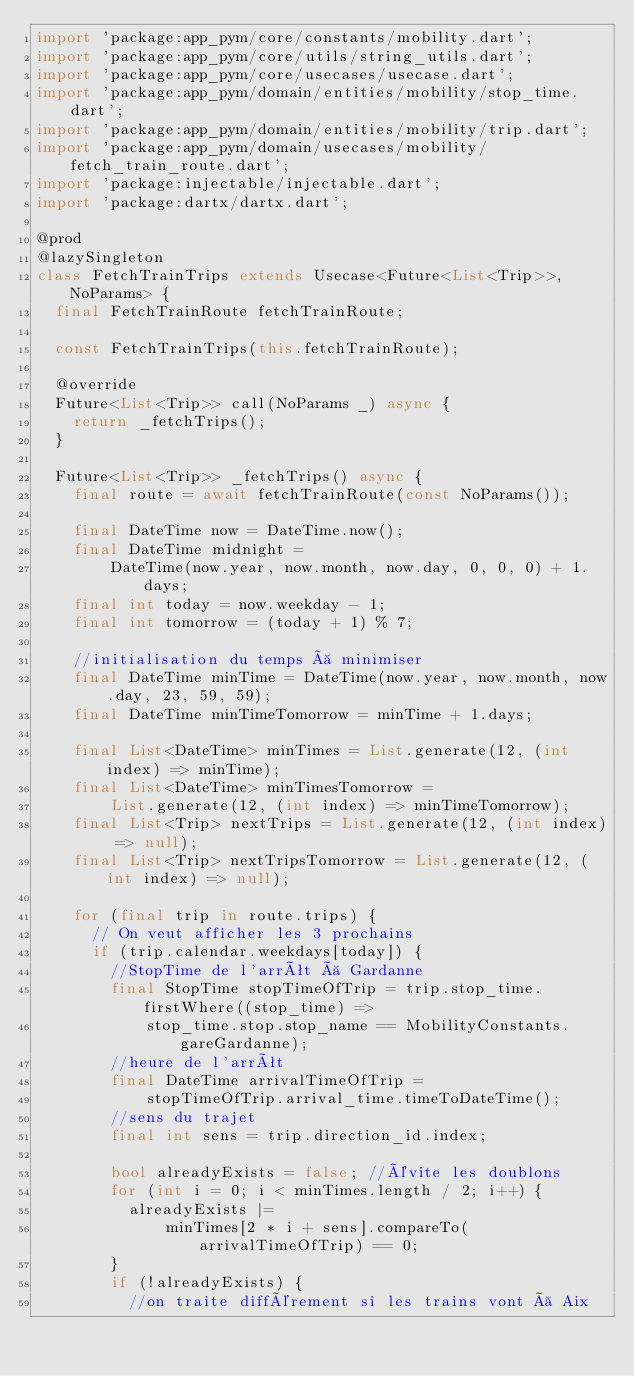Convert code to text. <code><loc_0><loc_0><loc_500><loc_500><_Dart_>import 'package:app_pym/core/constants/mobility.dart';
import 'package:app_pym/core/utils/string_utils.dart';
import 'package:app_pym/core/usecases/usecase.dart';
import 'package:app_pym/domain/entities/mobility/stop_time.dart';
import 'package:app_pym/domain/entities/mobility/trip.dart';
import 'package:app_pym/domain/usecases/mobility/fetch_train_route.dart';
import 'package:injectable/injectable.dart';
import 'package:dartx/dartx.dart';

@prod
@lazySingleton
class FetchTrainTrips extends Usecase<Future<List<Trip>>, NoParams> {
  final FetchTrainRoute fetchTrainRoute;

  const FetchTrainTrips(this.fetchTrainRoute);

  @override
  Future<List<Trip>> call(NoParams _) async {
    return _fetchTrips();
  }

  Future<List<Trip>> _fetchTrips() async {
    final route = await fetchTrainRoute(const NoParams());

    final DateTime now = DateTime.now();
    final DateTime midnight =
        DateTime(now.year, now.month, now.day, 0, 0, 0) + 1.days;
    final int today = now.weekday - 1;
    final int tomorrow = (today + 1) % 7;

    //initialisation du temps à minimiser
    final DateTime minTime = DateTime(now.year, now.month, now.day, 23, 59, 59);
    final DateTime minTimeTomorrow = minTime + 1.days;

    final List<DateTime> minTimes = List.generate(12, (int index) => minTime);
    final List<DateTime> minTimesTomorrow =
        List.generate(12, (int index) => minTimeTomorrow);
    final List<Trip> nextTrips = List.generate(12, (int index) => null);
    final List<Trip> nextTripsTomorrow = List.generate(12, (int index) => null);

    for (final trip in route.trips) {
      // On veut afficher les 3 prochains
      if (trip.calendar.weekdays[today]) {
        //StopTime de l'arrêt à Gardanne
        final StopTime stopTimeOfTrip = trip.stop_time.firstWhere((stop_time) =>
            stop_time.stop.stop_name == MobilityConstants.gareGardanne);
        //heure de l'arrêt
        final DateTime arrivalTimeOfTrip =
            stopTimeOfTrip.arrival_time.timeToDateTime();
        //sens du trajet
        final int sens = trip.direction_id.index;

        bool alreadyExists = false; //évite les doublons
        for (int i = 0; i < minTimes.length / 2; i++) {
          alreadyExists |=
              minTimes[2 * i + sens].compareTo(arrivalTimeOfTrip) == 0;
        }
        if (!alreadyExists) {
          //on traite différement si les trains vont à Aix</code> 